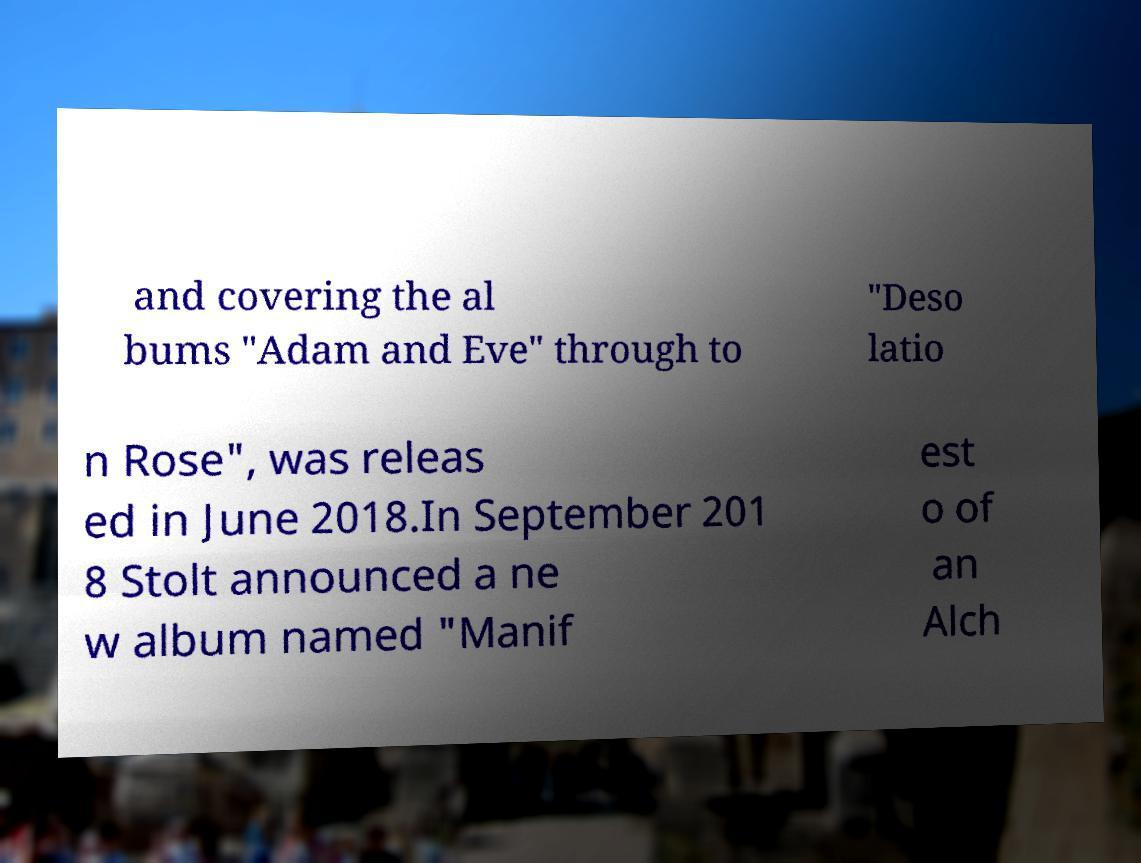Please identify and transcribe the text found in this image. and covering the al bums "Adam and Eve" through to "Deso latio n Rose", was releas ed in June 2018.In September 201 8 Stolt announced a ne w album named "Manif est o of an Alch 